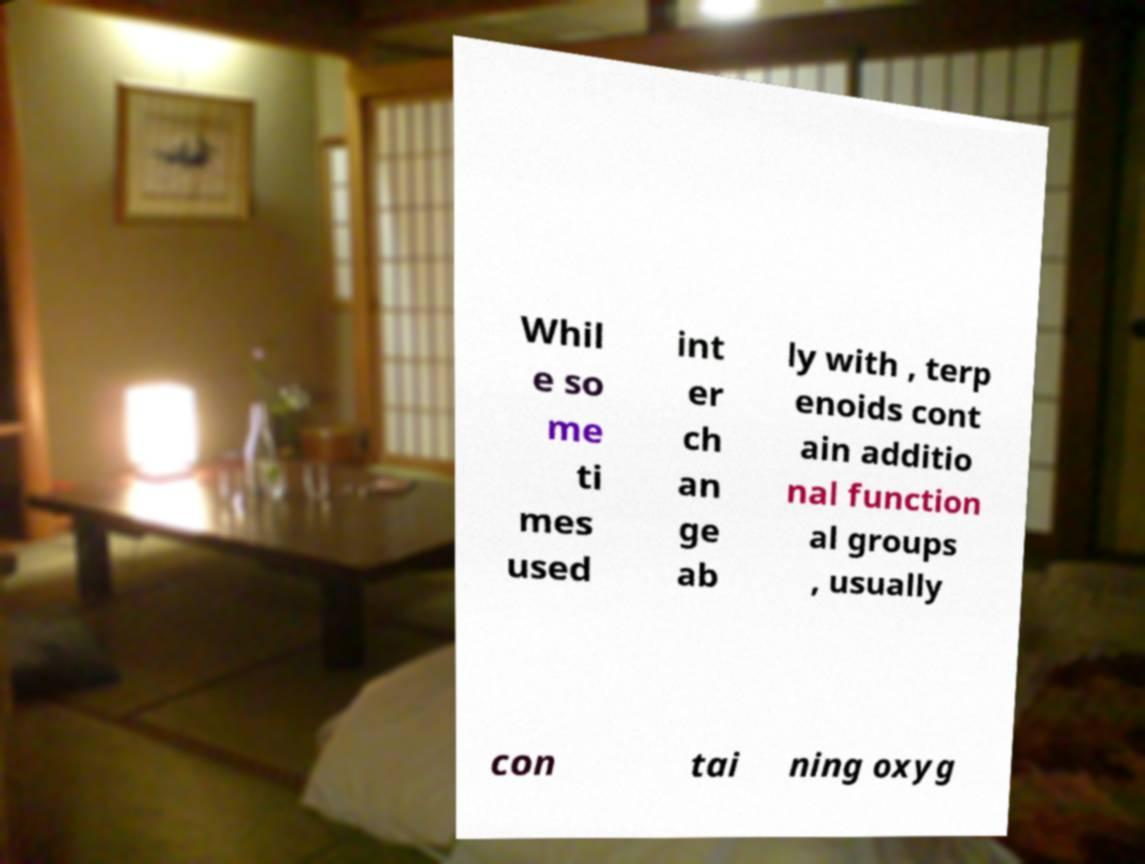Could you assist in decoding the text presented in this image and type it out clearly? Whil e so me ti mes used int er ch an ge ab ly with , terp enoids cont ain additio nal function al groups , usually con tai ning oxyg 